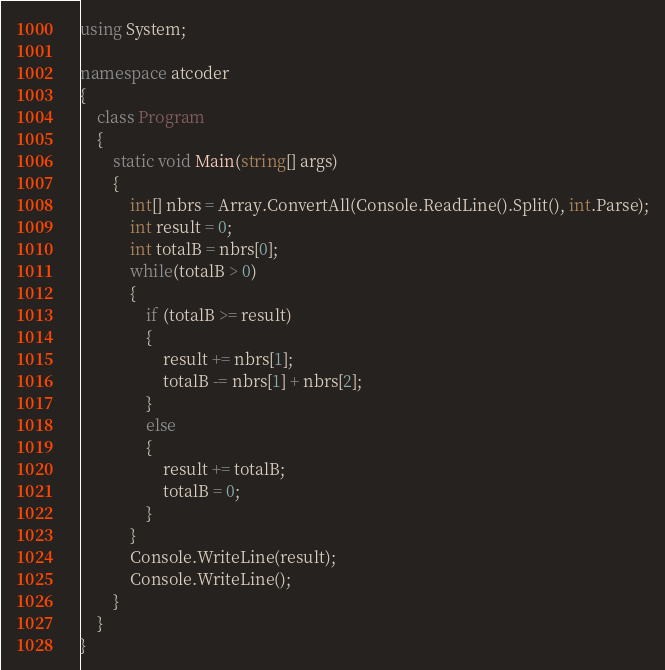Convert code to text. <code><loc_0><loc_0><loc_500><loc_500><_C#_>using System;

namespace atcoder
{
    class Program
    {
        static void Main(string[] args)
        {
            int[] nbrs = Array.ConvertAll(Console.ReadLine().Split(), int.Parse);
            int result = 0;
            int totalB = nbrs[0];
            while(totalB > 0)
            {
                if (totalB >= result)
                {
                    result += nbrs[1];
                    totalB -= nbrs[1] + nbrs[2];
                }
                else
                {
                    result += totalB;
                    totalB = 0;
                }
            }
            Console.WriteLine(result);
            Console.WriteLine();
        }
    }
}
</code> 